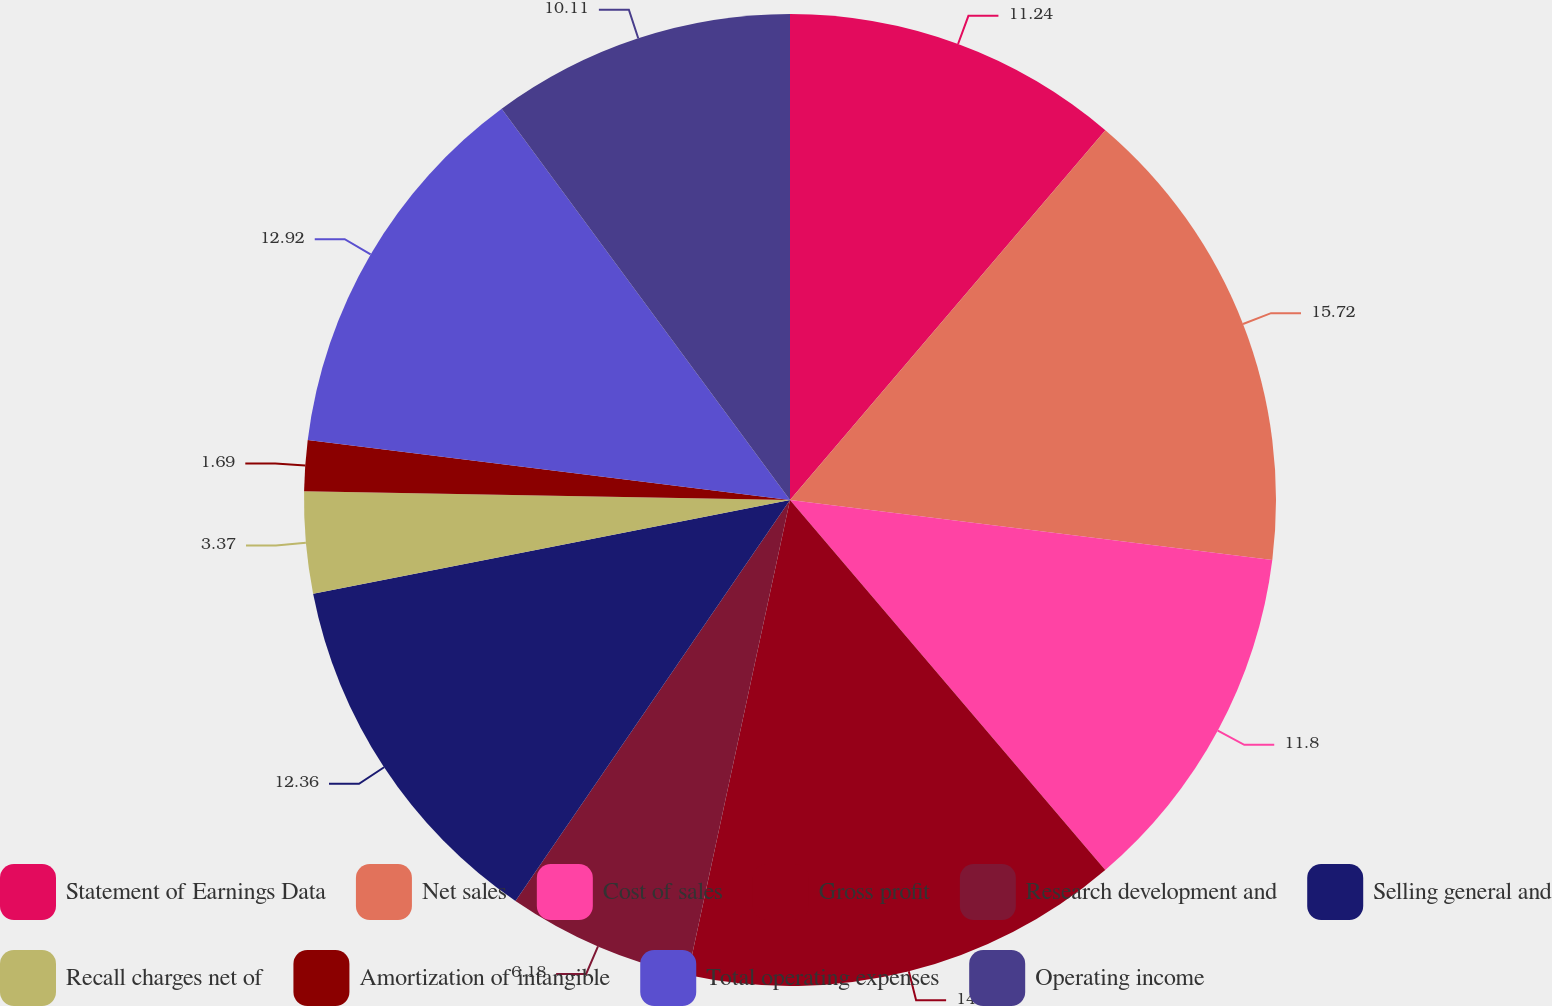Convert chart. <chart><loc_0><loc_0><loc_500><loc_500><pie_chart><fcel>Statement of Earnings Data<fcel>Net sales<fcel>Cost of sales<fcel>Gross profit<fcel>Research development and<fcel>Selling general and<fcel>Recall charges net of<fcel>Amortization of intangible<fcel>Total operating expenses<fcel>Operating income<nl><fcel>11.24%<fcel>15.73%<fcel>11.8%<fcel>14.61%<fcel>6.18%<fcel>12.36%<fcel>3.37%<fcel>1.69%<fcel>12.92%<fcel>10.11%<nl></chart> 